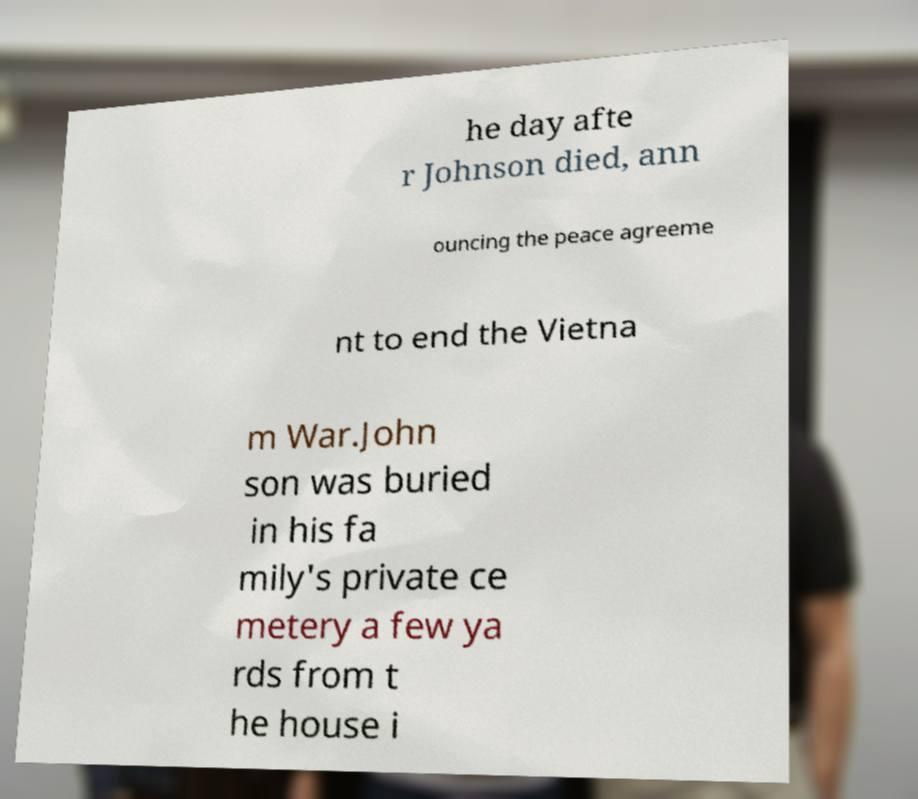Can you read and provide the text displayed in the image?This photo seems to have some interesting text. Can you extract and type it out for me? he day afte r Johnson died, ann ouncing the peace agreeme nt to end the Vietna m War.John son was buried in his fa mily's private ce metery a few ya rds from t he house i 